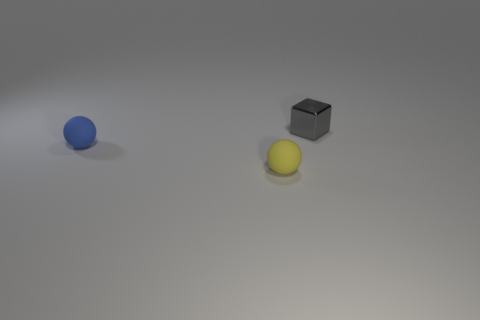Add 2 small gray rubber balls. How many objects exist? 5 Subtract all spheres. How many objects are left? 1 Add 2 small shiny cylinders. How many small shiny cylinders exist? 2 Subtract 0 purple blocks. How many objects are left? 3 Subtract all tiny matte things. Subtract all large red balls. How many objects are left? 1 Add 2 small matte objects. How many small matte objects are left? 4 